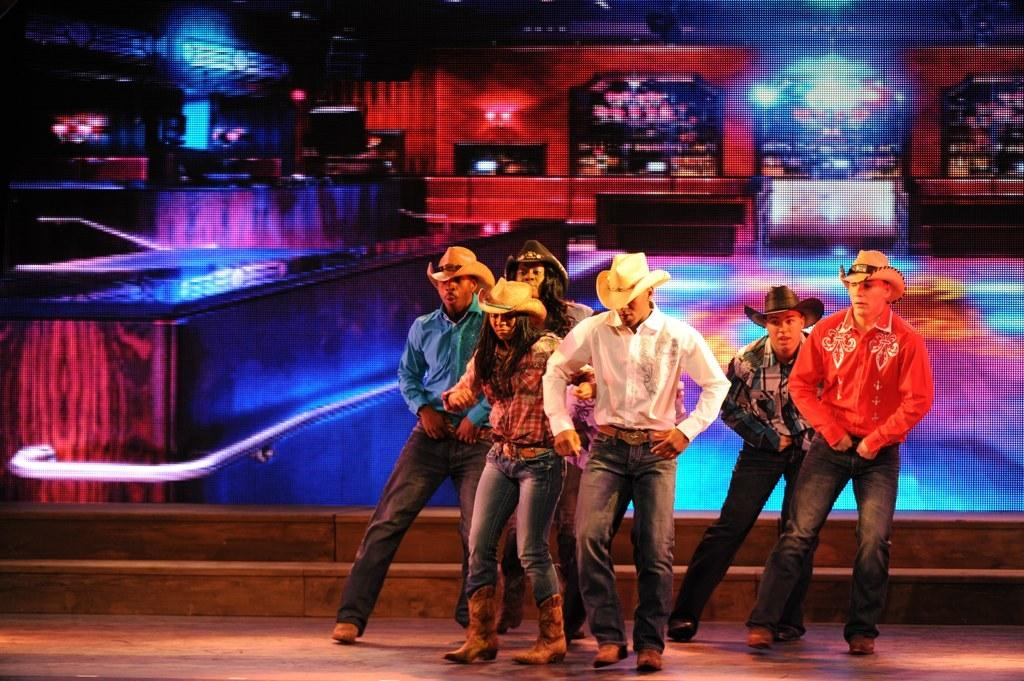How many people are in the image? There are six people in the image. What are the people doing in the image? The people are on the floor. What are the people wearing on their heads? The people are wearing hats. What can be seen in the background of the image? There are steps and a screen visible in the background of the image. What grade is the town in the image? There is no town present in the image, and therefore no grade can be assigned to it. 